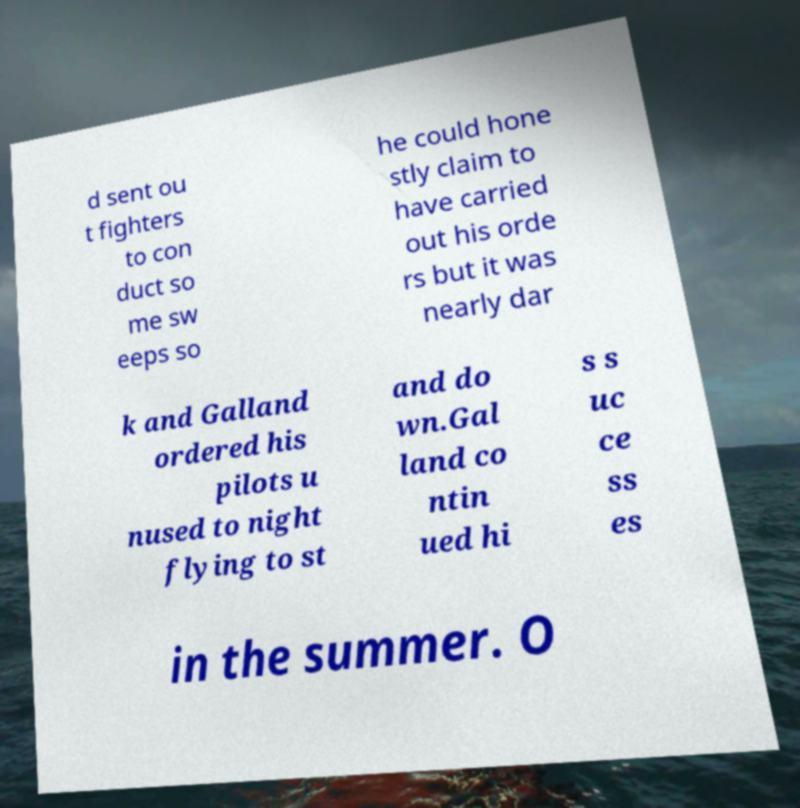For documentation purposes, I need the text within this image transcribed. Could you provide that? d sent ou t fighters to con duct so me sw eeps so he could hone stly claim to have carried out his orde rs but it was nearly dar k and Galland ordered his pilots u nused to night flying to st and do wn.Gal land co ntin ued hi s s uc ce ss es in the summer. O 